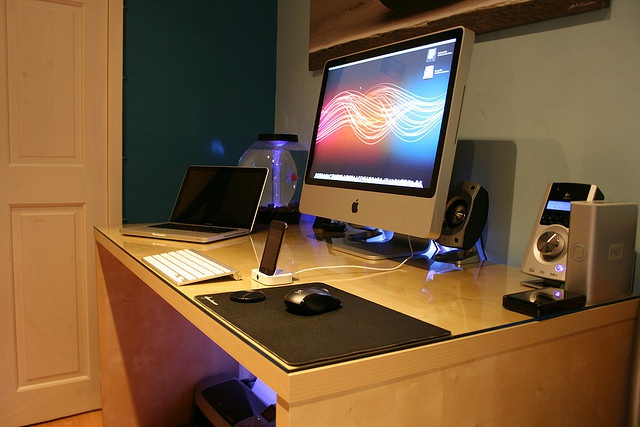Describe the objects in this image and their specific colors. I can see tv in gray, black, and white tones, laptop in gray, black, olive, and maroon tones, tv in gray, black, maroon, and tan tones, keyboard in gray, ivory, tan, and khaki tones, and mouse in gray, black, and maroon tones in this image. 